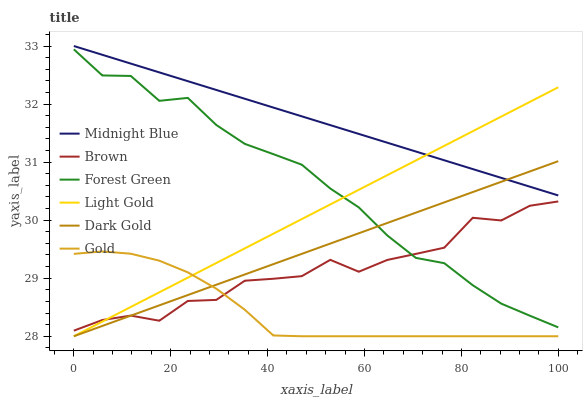Does Gold have the minimum area under the curve?
Answer yes or no. Yes. Does Midnight Blue have the minimum area under the curve?
Answer yes or no. No. Does Gold have the maximum area under the curve?
Answer yes or no. No. Is Brown the roughest?
Answer yes or no. Yes. Is Midnight Blue the smoothest?
Answer yes or no. No. Is Midnight Blue the roughest?
Answer yes or no. No. Does Midnight Blue have the lowest value?
Answer yes or no. No. Does Gold have the highest value?
Answer yes or no. No. Is Gold less than Forest Green?
Answer yes or no. Yes. Is Forest Green greater than Gold?
Answer yes or no. Yes. Does Gold intersect Forest Green?
Answer yes or no. No. 